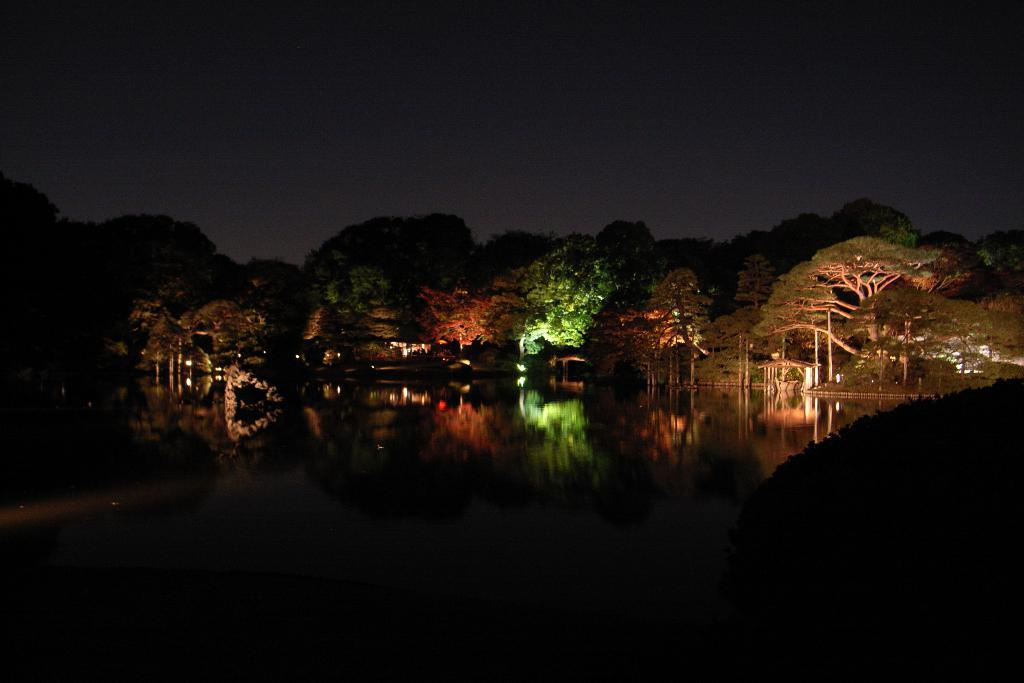What is the primary element visible in the image? There is water in the image. What type of vegetation can be seen in the image? There are trees in the image. What is visible in the background of the image? The sky is visible in the background of the image. What type of club is being used to collect eggs in the image? There is no club or eggs present in the image; it features water and trees with the sky visible in the background. 